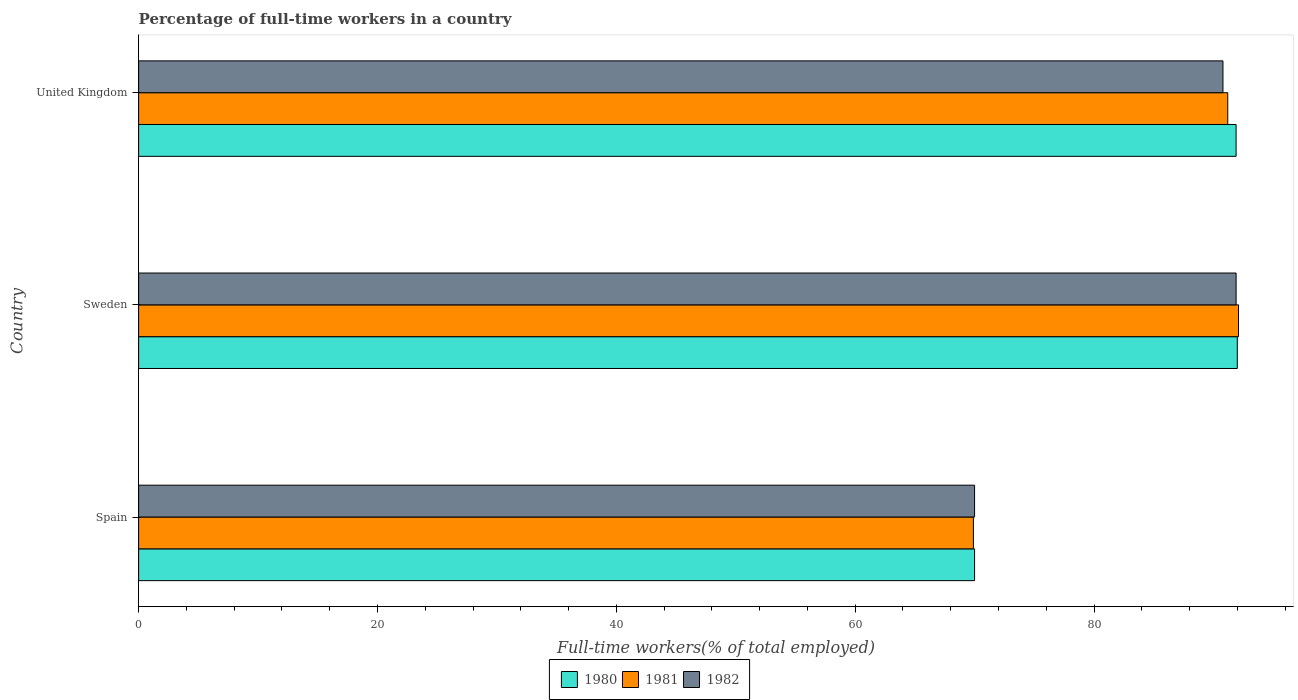How many different coloured bars are there?
Ensure brevity in your answer.  3. How many groups of bars are there?
Your response must be concise. 3. Are the number of bars per tick equal to the number of legend labels?
Offer a terse response. Yes. How many bars are there on the 3rd tick from the top?
Offer a terse response. 3. How many bars are there on the 2nd tick from the bottom?
Provide a succinct answer. 3. In how many cases, is the number of bars for a given country not equal to the number of legend labels?
Offer a very short reply. 0. What is the percentage of full-time workers in 1981 in Sweden?
Your answer should be very brief. 92.1. Across all countries, what is the maximum percentage of full-time workers in 1980?
Keep it short and to the point. 92. Across all countries, what is the minimum percentage of full-time workers in 1980?
Give a very brief answer. 70. In which country was the percentage of full-time workers in 1981 maximum?
Keep it short and to the point. Sweden. What is the total percentage of full-time workers in 1980 in the graph?
Provide a short and direct response. 253.9. What is the difference between the percentage of full-time workers in 1982 in Spain and that in Sweden?
Your answer should be compact. -21.9. What is the average percentage of full-time workers in 1981 per country?
Make the answer very short. 84.4. What is the difference between the percentage of full-time workers in 1980 and percentage of full-time workers in 1982 in United Kingdom?
Provide a succinct answer. 1.1. In how many countries, is the percentage of full-time workers in 1980 greater than 92 %?
Offer a very short reply. 0. What is the ratio of the percentage of full-time workers in 1980 in Sweden to that in United Kingdom?
Keep it short and to the point. 1. What is the difference between the highest and the second highest percentage of full-time workers in 1980?
Your answer should be very brief. 0.1. Is the sum of the percentage of full-time workers in 1981 in Spain and Sweden greater than the maximum percentage of full-time workers in 1980 across all countries?
Provide a succinct answer. Yes. How many bars are there?
Provide a short and direct response. 9. Are all the bars in the graph horizontal?
Keep it short and to the point. Yes. What is the difference between two consecutive major ticks on the X-axis?
Provide a succinct answer. 20. Are the values on the major ticks of X-axis written in scientific E-notation?
Your answer should be compact. No. Does the graph contain grids?
Give a very brief answer. No. How many legend labels are there?
Your answer should be compact. 3. How are the legend labels stacked?
Your response must be concise. Horizontal. What is the title of the graph?
Provide a succinct answer. Percentage of full-time workers in a country. Does "1960" appear as one of the legend labels in the graph?
Your response must be concise. No. What is the label or title of the X-axis?
Ensure brevity in your answer.  Full-time workers(% of total employed). What is the Full-time workers(% of total employed) in 1980 in Spain?
Offer a terse response. 70. What is the Full-time workers(% of total employed) in 1981 in Spain?
Your answer should be compact. 69.9. What is the Full-time workers(% of total employed) of 1980 in Sweden?
Keep it short and to the point. 92. What is the Full-time workers(% of total employed) in 1981 in Sweden?
Keep it short and to the point. 92.1. What is the Full-time workers(% of total employed) in 1982 in Sweden?
Provide a short and direct response. 91.9. What is the Full-time workers(% of total employed) of 1980 in United Kingdom?
Give a very brief answer. 91.9. What is the Full-time workers(% of total employed) in 1981 in United Kingdom?
Your answer should be compact. 91.2. What is the Full-time workers(% of total employed) in 1982 in United Kingdom?
Keep it short and to the point. 90.8. Across all countries, what is the maximum Full-time workers(% of total employed) of 1980?
Keep it short and to the point. 92. Across all countries, what is the maximum Full-time workers(% of total employed) of 1981?
Make the answer very short. 92.1. Across all countries, what is the maximum Full-time workers(% of total employed) of 1982?
Your answer should be very brief. 91.9. Across all countries, what is the minimum Full-time workers(% of total employed) of 1980?
Your answer should be very brief. 70. Across all countries, what is the minimum Full-time workers(% of total employed) of 1981?
Give a very brief answer. 69.9. Across all countries, what is the minimum Full-time workers(% of total employed) in 1982?
Your answer should be compact. 70. What is the total Full-time workers(% of total employed) of 1980 in the graph?
Provide a succinct answer. 253.9. What is the total Full-time workers(% of total employed) of 1981 in the graph?
Provide a succinct answer. 253.2. What is the total Full-time workers(% of total employed) in 1982 in the graph?
Provide a short and direct response. 252.7. What is the difference between the Full-time workers(% of total employed) in 1980 in Spain and that in Sweden?
Provide a succinct answer. -22. What is the difference between the Full-time workers(% of total employed) in 1981 in Spain and that in Sweden?
Offer a terse response. -22.2. What is the difference between the Full-time workers(% of total employed) in 1982 in Spain and that in Sweden?
Provide a succinct answer. -21.9. What is the difference between the Full-time workers(% of total employed) of 1980 in Spain and that in United Kingdom?
Keep it short and to the point. -21.9. What is the difference between the Full-time workers(% of total employed) in 1981 in Spain and that in United Kingdom?
Make the answer very short. -21.3. What is the difference between the Full-time workers(% of total employed) in 1982 in Spain and that in United Kingdom?
Give a very brief answer. -20.8. What is the difference between the Full-time workers(% of total employed) of 1980 in Sweden and that in United Kingdom?
Provide a succinct answer. 0.1. What is the difference between the Full-time workers(% of total employed) of 1982 in Sweden and that in United Kingdom?
Keep it short and to the point. 1.1. What is the difference between the Full-time workers(% of total employed) of 1980 in Spain and the Full-time workers(% of total employed) of 1981 in Sweden?
Your answer should be very brief. -22.1. What is the difference between the Full-time workers(% of total employed) of 1980 in Spain and the Full-time workers(% of total employed) of 1982 in Sweden?
Keep it short and to the point. -21.9. What is the difference between the Full-time workers(% of total employed) in 1980 in Spain and the Full-time workers(% of total employed) in 1981 in United Kingdom?
Make the answer very short. -21.2. What is the difference between the Full-time workers(% of total employed) in 1980 in Spain and the Full-time workers(% of total employed) in 1982 in United Kingdom?
Your answer should be compact. -20.8. What is the difference between the Full-time workers(% of total employed) of 1981 in Spain and the Full-time workers(% of total employed) of 1982 in United Kingdom?
Provide a short and direct response. -20.9. What is the difference between the Full-time workers(% of total employed) of 1980 in Sweden and the Full-time workers(% of total employed) of 1981 in United Kingdom?
Keep it short and to the point. 0.8. What is the difference between the Full-time workers(% of total employed) in 1980 in Sweden and the Full-time workers(% of total employed) in 1982 in United Kingdom?
Your answer should be very brief. 1.2. What is the difference between the Full-time workers(% of total employed) in 1981 in Sweden and the Full-time workers(% of total employed) in 1982 in United Kingdom?
Your answer should be compact. 1.3. What is the average Full-time workers(% of total employed) of 1980 per country?
Offer a terse response. 84.63. What is the average Full-time workers(% of total employed) in 1981 per country?
Provide a succinct answer. 84.4. What is the average Full-time workers(% of total employed) of 1982 per country?
Keep it short and to the point. 84.23. What is the difference between the Full-time workers(% of total employed) of 1980 and Full-time workers(% of total employed) of 1981 in Spain?
Give a very brief answer. 0.1. What is the difference between the Full-time workers(% of total employed) in 1981 and Full-time workers(% of total employed) in 1982 in Spain?
Your answer should be very brief. -0.1. What is the difference between the Full-time workers(% of total employed) of 1980 and Full-time workers(% of total employed) of 1981 in Sweden?
Make the answer very short. -0.1. What is the difference between the Full-time workers(% of total employed) in 1980 and Full-time workers(% of total employed) in 1982 in Sweden?
Offer a very short reply. 0.1. What is the difference between the Full-time workers(% of total employed) in 1980 and Full-time workers(% of total employed) in 1981 in United Kingdom?
Give a very brief answer. 0.7. What is the difference between the Full-time workers(% of total employed) in 1980 and Full-time workers(% of total employed) in 1982 in United Kingdom?
Offer a terse response. 1.1. What is the ratio of the Full-time workers(% of total employed) of 1980 in Spain to that in Sweden?
Your response must be concise. 0.76. What is the ratio of the Full-time workers(% of total employed) in 1981 in Spain to that in Sweden?
Provide a short and direct response. 0.76. What is the ratio of the Full-time workers(% of total employed) in 1982 in Spain to that in Sweden?
Provide a short and direct response. 0.76. What is the ratio of the Full-time workers(% of total employed) in 1980 in Spain to that in United Kingdom?
Provide a succinct answer. 0.76. What is the ratio of the Full-time workers(% of total employed) in 1981 in Spain to that in United Kingdom?
Make the answer very short. 0.77. What is the ratio of the Full-time workers(% of total employed) of 1982 in Spain to that in United Kingdom?
Ensure brevity in your answer.  0.77. What is the ratio of the Full-time workers(% of total employed) of 1981 in Sweden to that in United Kingdom?
Offer a very short reply. 1.01. What is the ratio of the Full-time workers(% of total employed) in 1982 in Sweden to that in United Kingdom?
Your answer should be compact. 1.01. What is the difference between the highest and the second highest Full-time workers(% of total employed) in 1980?
Give a very brief answer. 0.1. What is the difference between the highest and the second highest Full-time workers(% of total employed) in 1981?
Ensure brevity in your answer.  0.9. What is the difference between the highest and the lowest Full-time workers(% of total employed) in 1981?
Give a very brief answer. 22.2. What is the difference between the highest and the lowest Full-time workers(% of total employed) of 1982?
Your answer should be very brief. 21.9. 